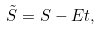<formula> <loc_0><loc_0><loc_500><loc_500>\tilde { S } = S - E t ,</formula> 